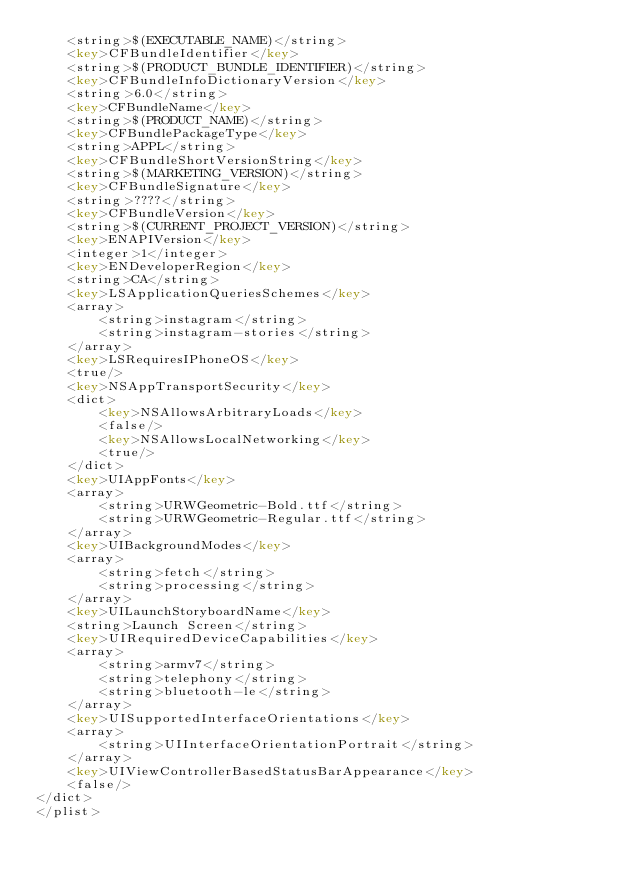Convert code to text. <code><loc_0><loc_0><loc_500><loc_500><_XML_>	<string>$(EXECUTABLE_NAME)</string>
	<key>CFBundleIdentifier</key>
	<string>$(PRODUCT_BUNDLE_IDENTIFIER)</string>
	<key>CFBundleInfoDictionaryVersion</key>
	<string>6.0</string>
	<key>CFBundleName</key>
	<string>$(PRODUCT_NAME)</string>
	<key>CFBundlePackageType</key>
	<string>APPL</string>
	<key>CFBundleShortVersionString</key>
	<string>$(MARKETING_VERSION)</string>
	<key>CFBundleSignature</key>
	<string>????</string>
	<key>CFBundleVersion</key>
	<string>$(CURRENT_PROJECT_VERSION)</string>
	<key>ENAPIVersion</key>
	<integer>1</integer>
	<key>ENDeveloperRegion</key>
	<string>CA</string>
	<key>LSApplicationQueriesSchemes</key>
	<array>
		<string>instagram</string>
		<string>instagram-stories</string>
	</array>
	<key>LSRequiresIPhoneOS</key>
	<true/>
	<key>NSAppTransportSecurity</key>
	<dict>
		<key>NSAllowsArbitraryLoads</key>
		<false/>
		<key>NSAllowsLocalNetworking</key>
		<true/>
	</dict>
	<key>UIAppFonts</key>
	<array>
		<string>URWGeometric-Bold.ttf</string>
		<string>URWGeometric-Regular.ttf</string>
	</array>
	<key>UIBackgroundModes</key>
	<array>
		<string>fetch</string>
		<string>processing</string>
	</array>
	<key>UILaunchStoryboardName</key>
	<string>Launch Screen</string>
	<key>UIRequiredDeviceCapabilities</key>
	<array>
		<string>armv7</string>
		<string>telephony</string>
		<string>bluetooth-le</string>
	</array>
	<key>UISupportedInterfaceOrientations</key>
	<array>
		<string>UIInterfaceOrientationPortrait</string>
	</array>
	<key>UIViewControllerBasedStatusBarAppearance</key>
	<false/>
</dict>
</plist>
</code> 